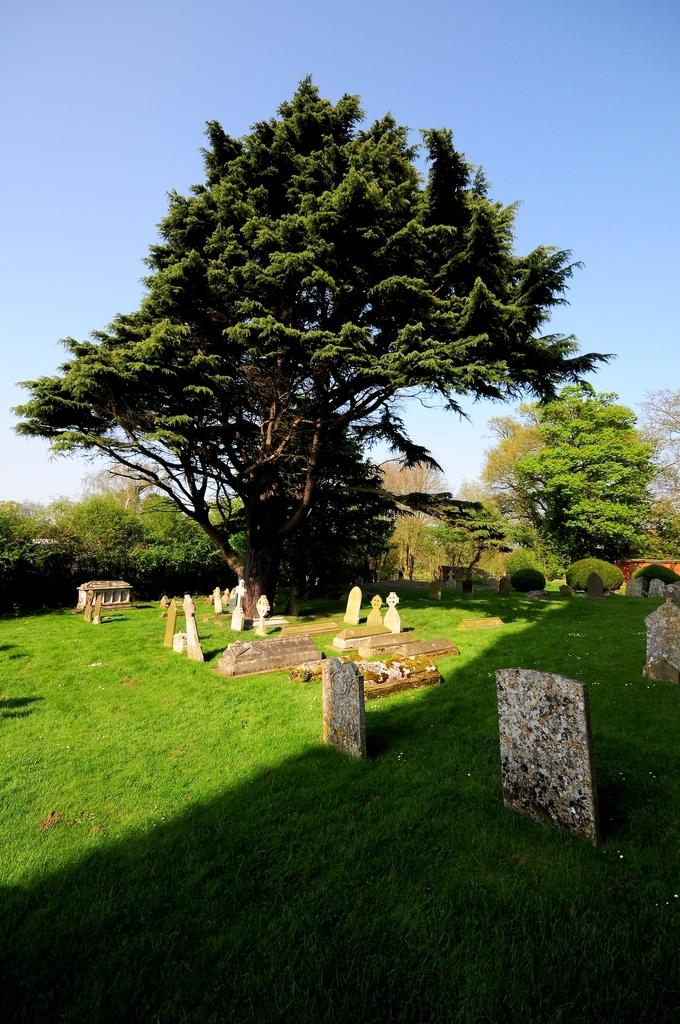What type of environment is depicted in the image? There is greenery in the image, suggesting a natural or outdoor setting. What specific objects or features can be seen in the image? There are graves in the image. Can you see any flies buzzing around the graves in the image? There is no mention of flies in the image, so it cannot be determined if any are present. Is your aunt wearing a sock in the image? There is no reference to an aunt or a sock in the image, so it cannot be determined if either is present. 